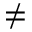Convert formula to latex. <formula><loc_0><loc_0><loc_500><loc_500>\neq</formula> 